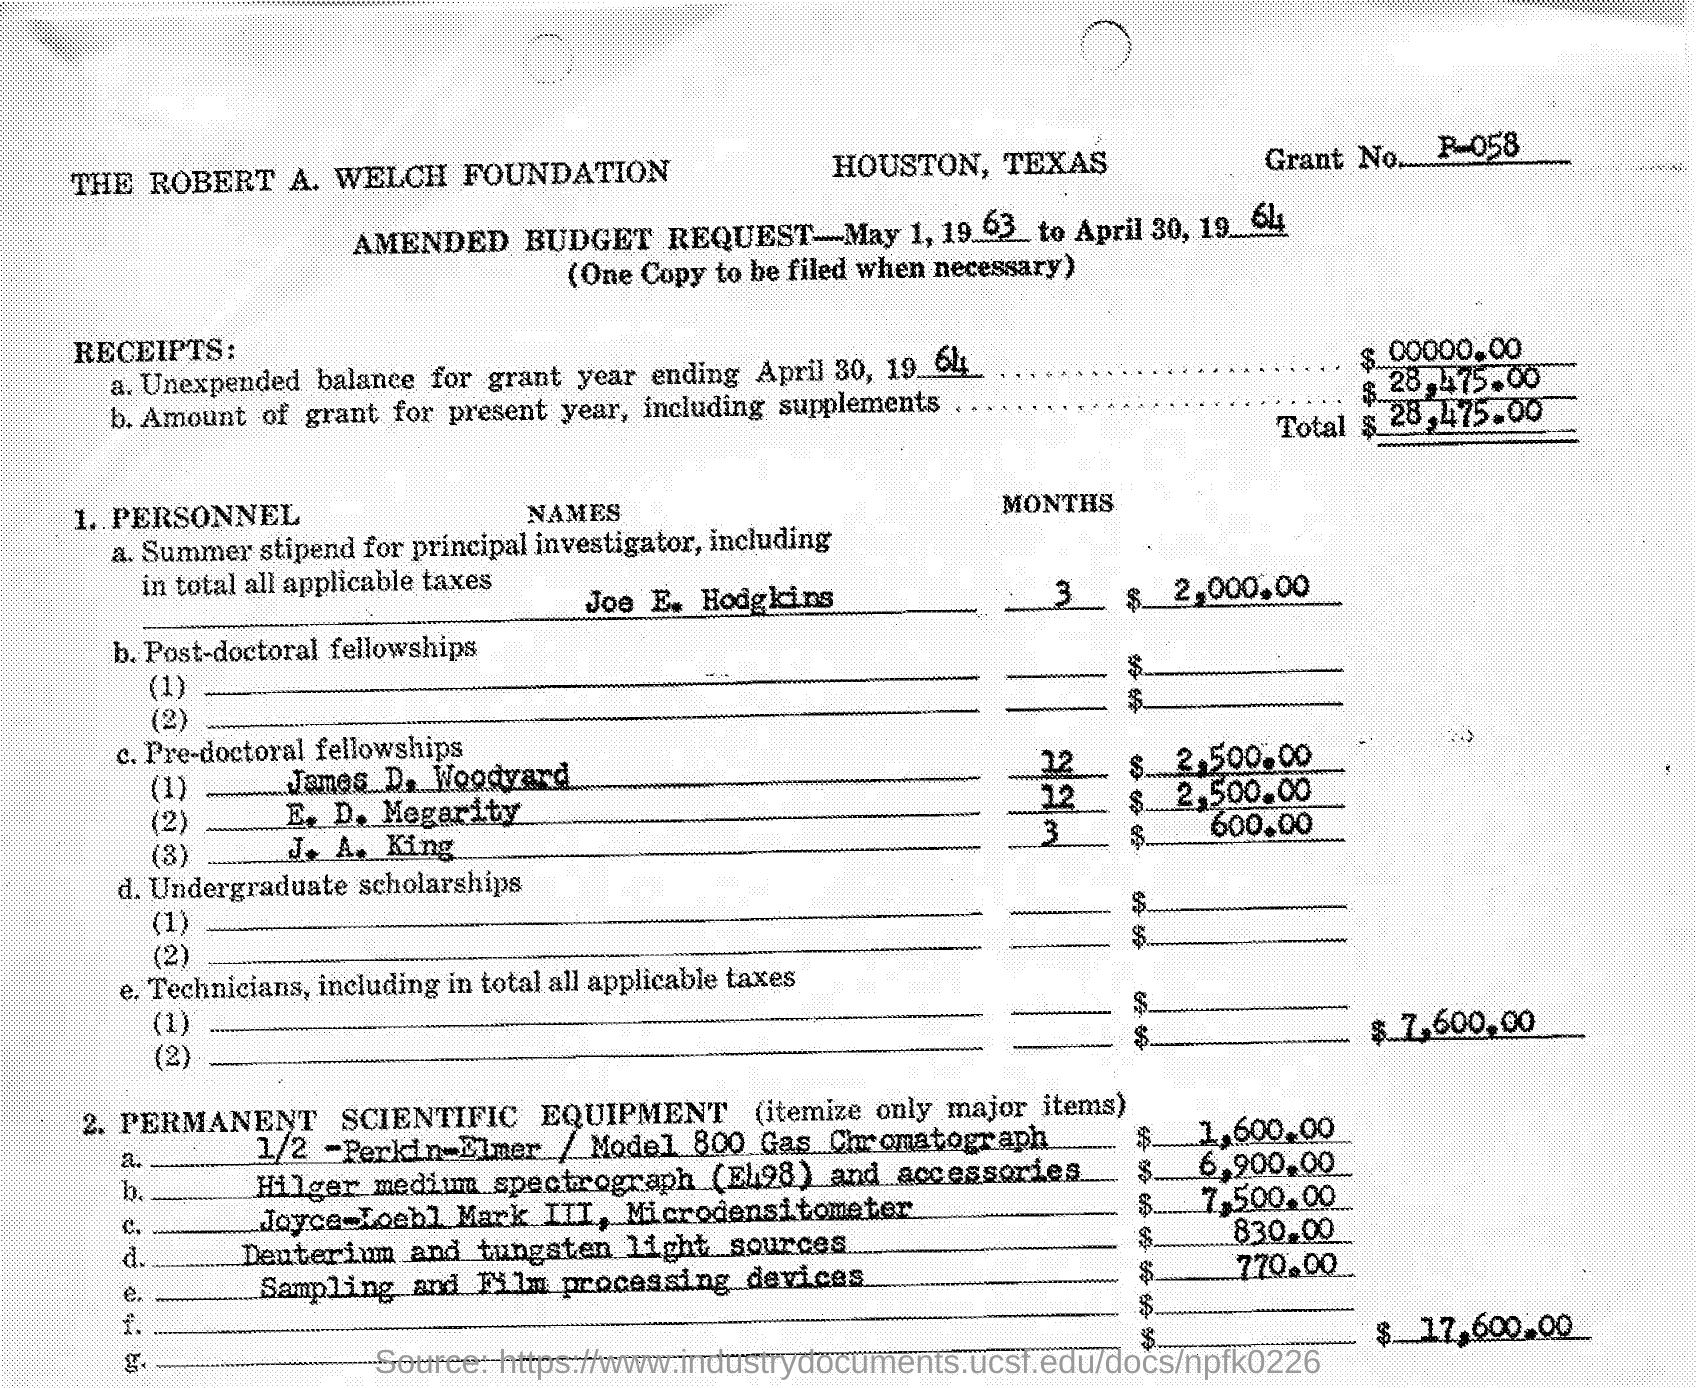What is the duration of AMENDED BUDGET REQUEST?
Offer a very short reply. May 1, 1963 to April 30, 1964. How many dollars were granted for present year, including supplements?
Offer a very short reply. $28,475.00. What is the amount paid as Summer stipend for Joe E. Hodgkins?
Offer a terse response. $ 2,000.00. Whats the TOTAL in PERSONNEL?
Offer a very short reply. $7,600.00. How many months did J. A. King presumed his pre-doctor fellowship?
Keep it short and to the point. 3. What's the cost of sampling and film processing device?
Ensure brevity in your answer.  $770.00. Name the equipment which costs 7,500.00 dollars?
Your response must be concise. Joyce-Loebl Mark III, Microdensitometer. How many dollars were spent in total for PERMANENT SCIENTIFIC EQUIPMENT?
Offer a very short reply. $ 17,600.00. 